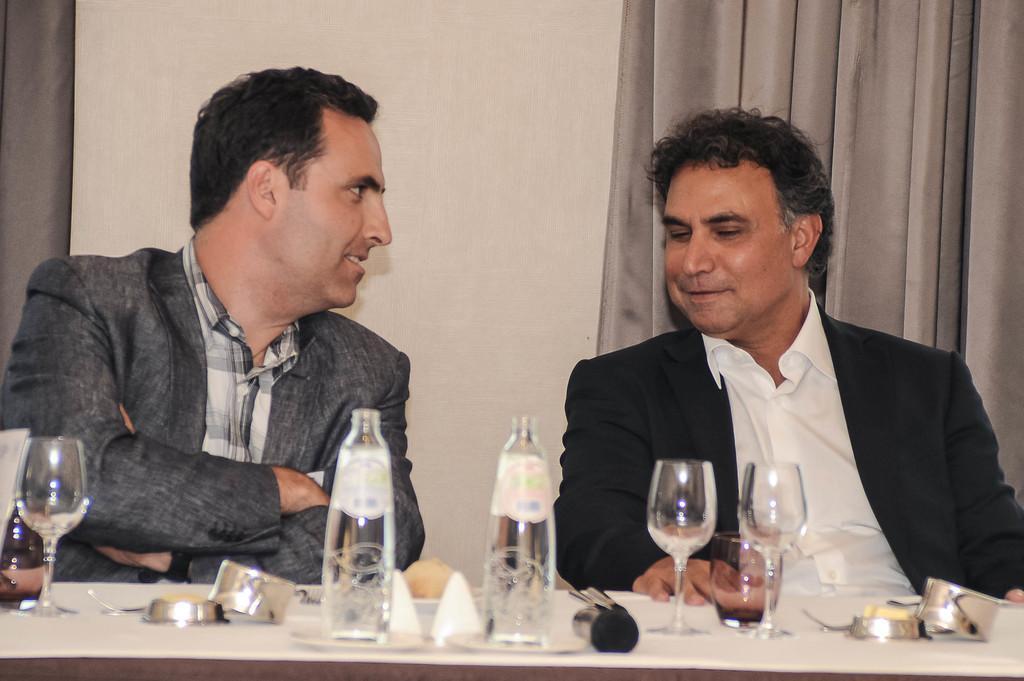Describe this image in one or two sentences. In this image I can see two persons walking and I can see few glasses, bottles and few objects on the table. In the background I can see the curtain in gray color and the wall is in cream color. 